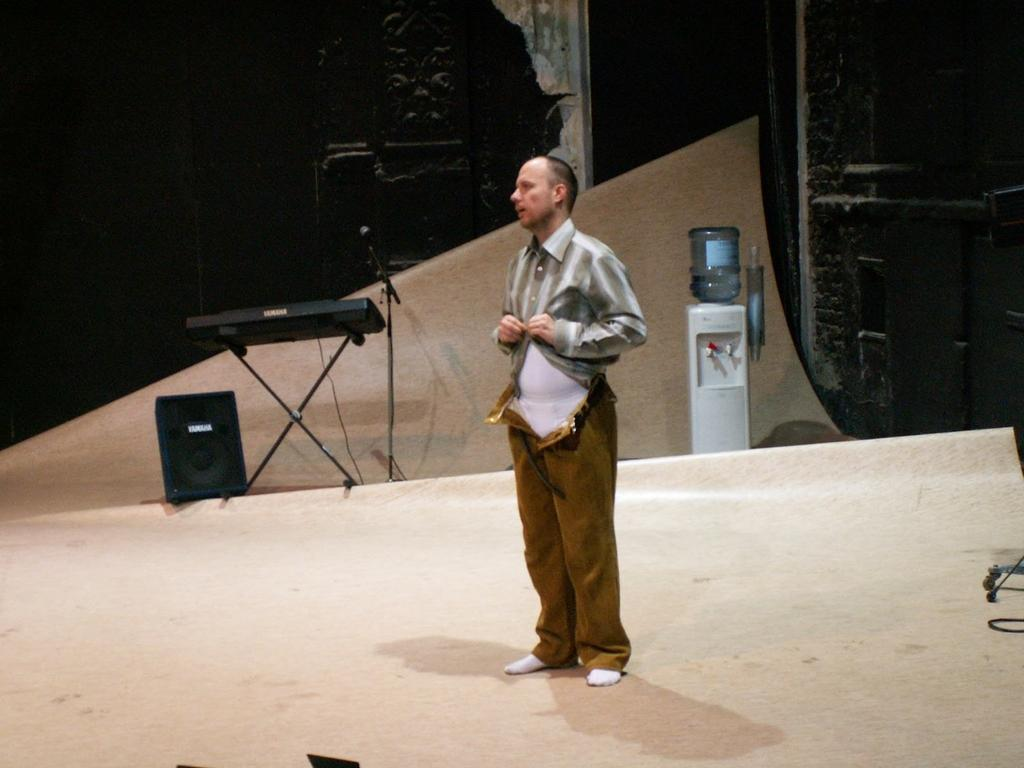Who is present in the image? There is a man in the image. What equipment is visible in the image? There is a speaker, a keyboard, and a microphone in the image. Can you describe any objects in the background of the image? There is a bottle and a water filter in the background of the image. What type of muscle is being exercised by the man in the image? There is no indication of the man exercising any muscles in the image. Can you see the father of the man in the image? The provided facts do not mention a father, so it cannot be determined if he is present in the image. 